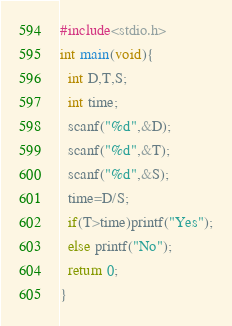Convert code to text. <code><loc_0><loc_0><loc_500><loc_500><_C_>#include<stdio.h>
int main(void){
  int D,T,S;
  int time;
  scanf("%d",&D);
  scanf("%d",&T);
  scanf("%d",&S);
  time=D/S;
  if(T>time)printf("Yes");
  else printf("No");
  return 0;
}</code> 